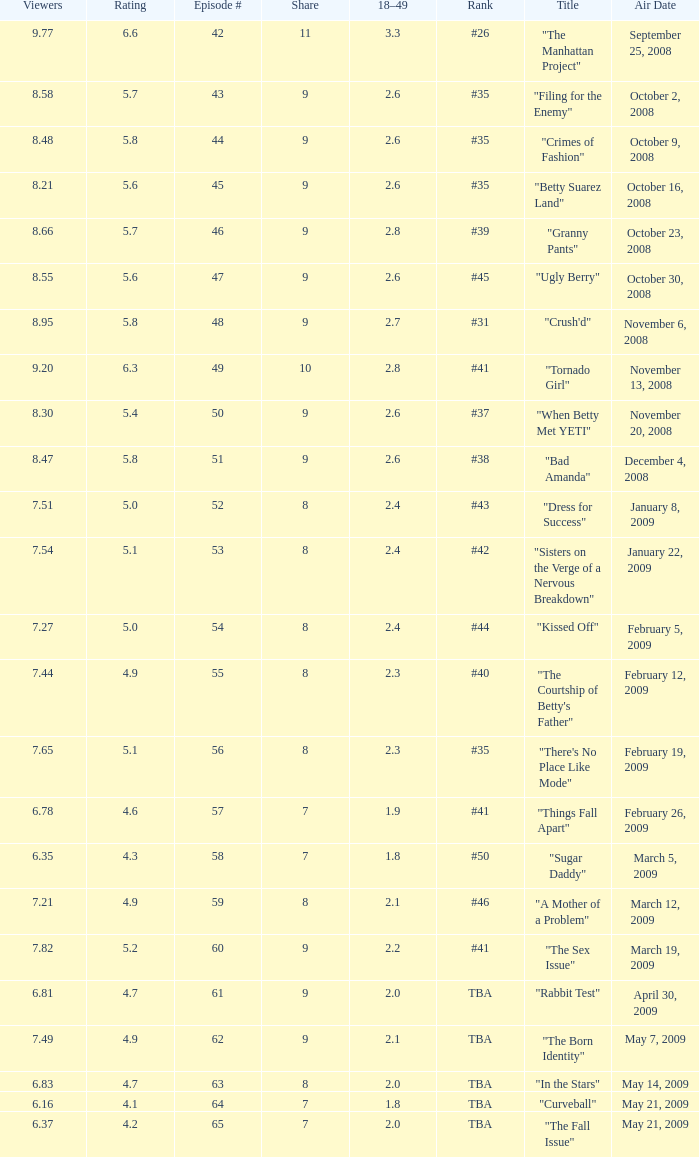What is the average Episode # with a share of 9, and #35 is rank and less than 8.21 viewers? None. 